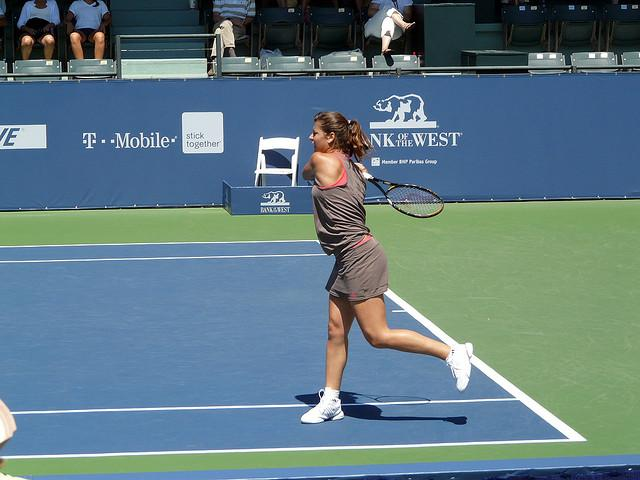What is the middle advertisement on the blue wall about?

Choices:
A) athletic help
B) banking
C) suicide hotline
D) cellular service cellular service 